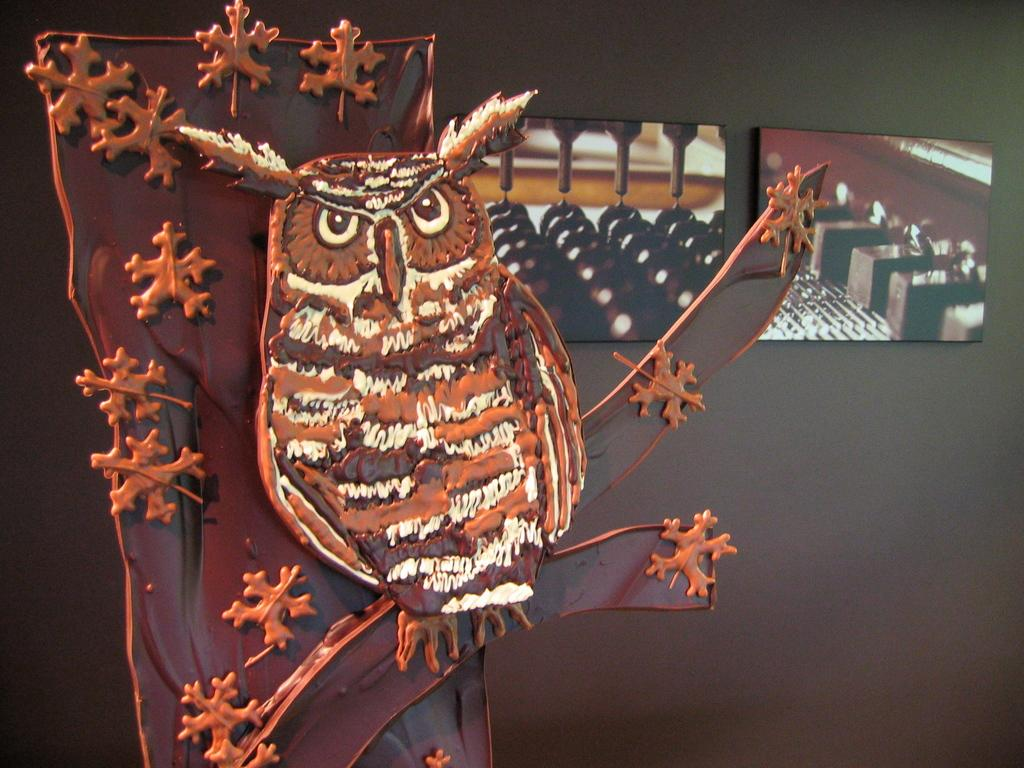What animal is present in the image? There is an owl in the image. Where is the owl located? The owl is sitting on a tree. What can be seen in the background of the image? There is a wall in the background of the image. What objects are in front of the wall? There are two photo frames in front of the wall. What kind of trouble is the girl causing in the image? There is no girl present in the image, so it is not possible to determine if she is causing any trouble. 